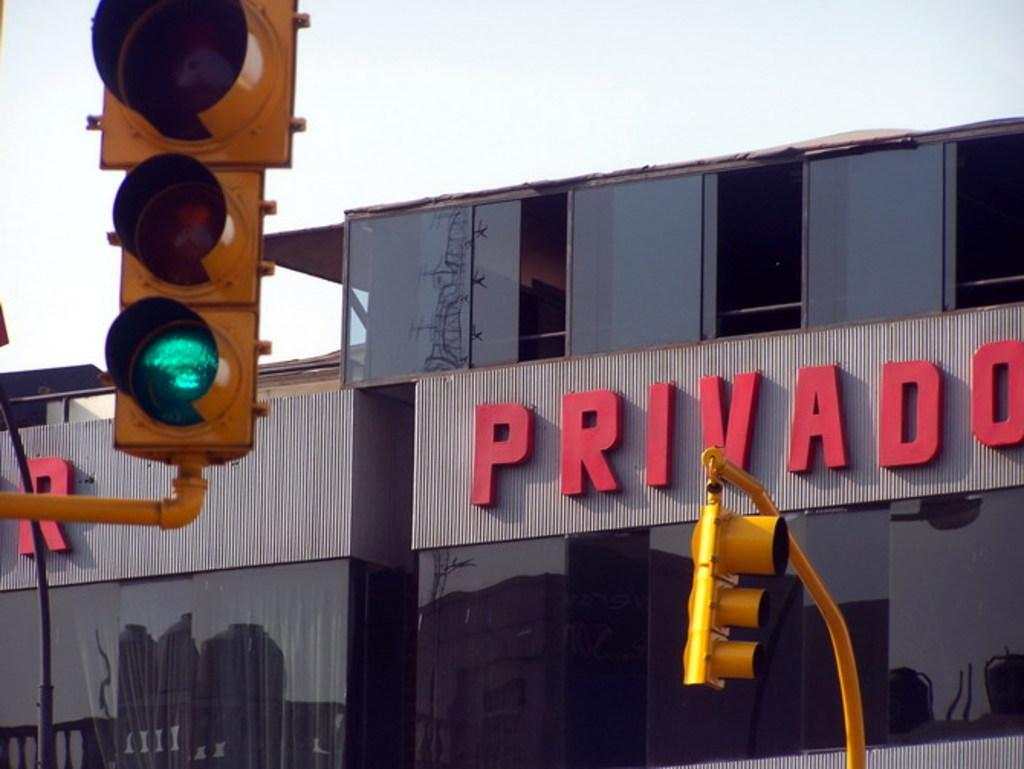Provide a one-sentence caption for the provided image. A traffic light with Privado building in the background. 